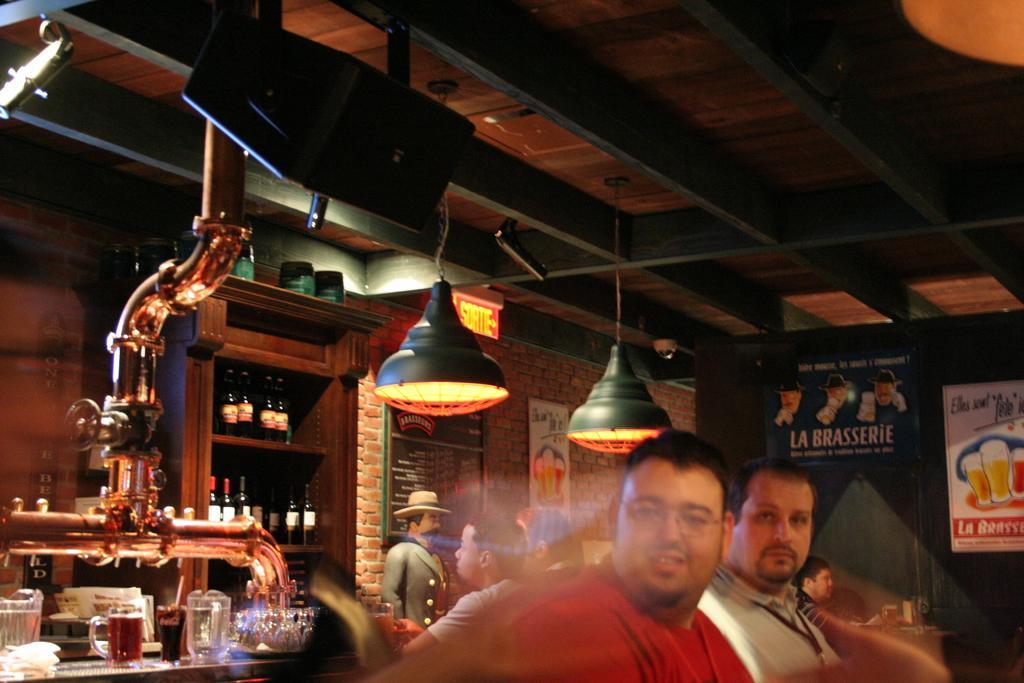How would you summarize this image in a sentence or two? In this picture we can see some people on the path and on the left side of the people there is a statue and the glasses are on an object. Behind the glasses there is a pipe and bottles in the shelves and at the top there are lights hanged to the roof. Behind the people there is a wall with posters and a board. 